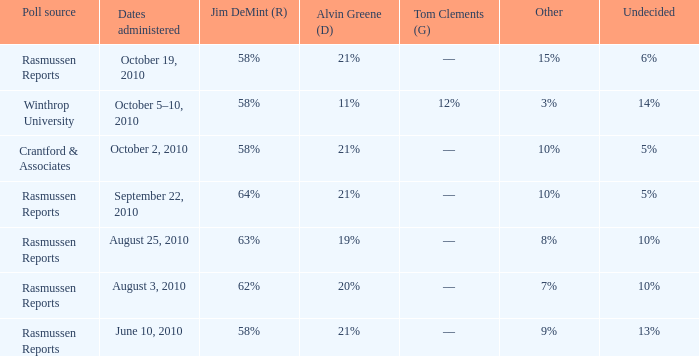What was the vote for Alvin Green when other was 9%? 21%. 